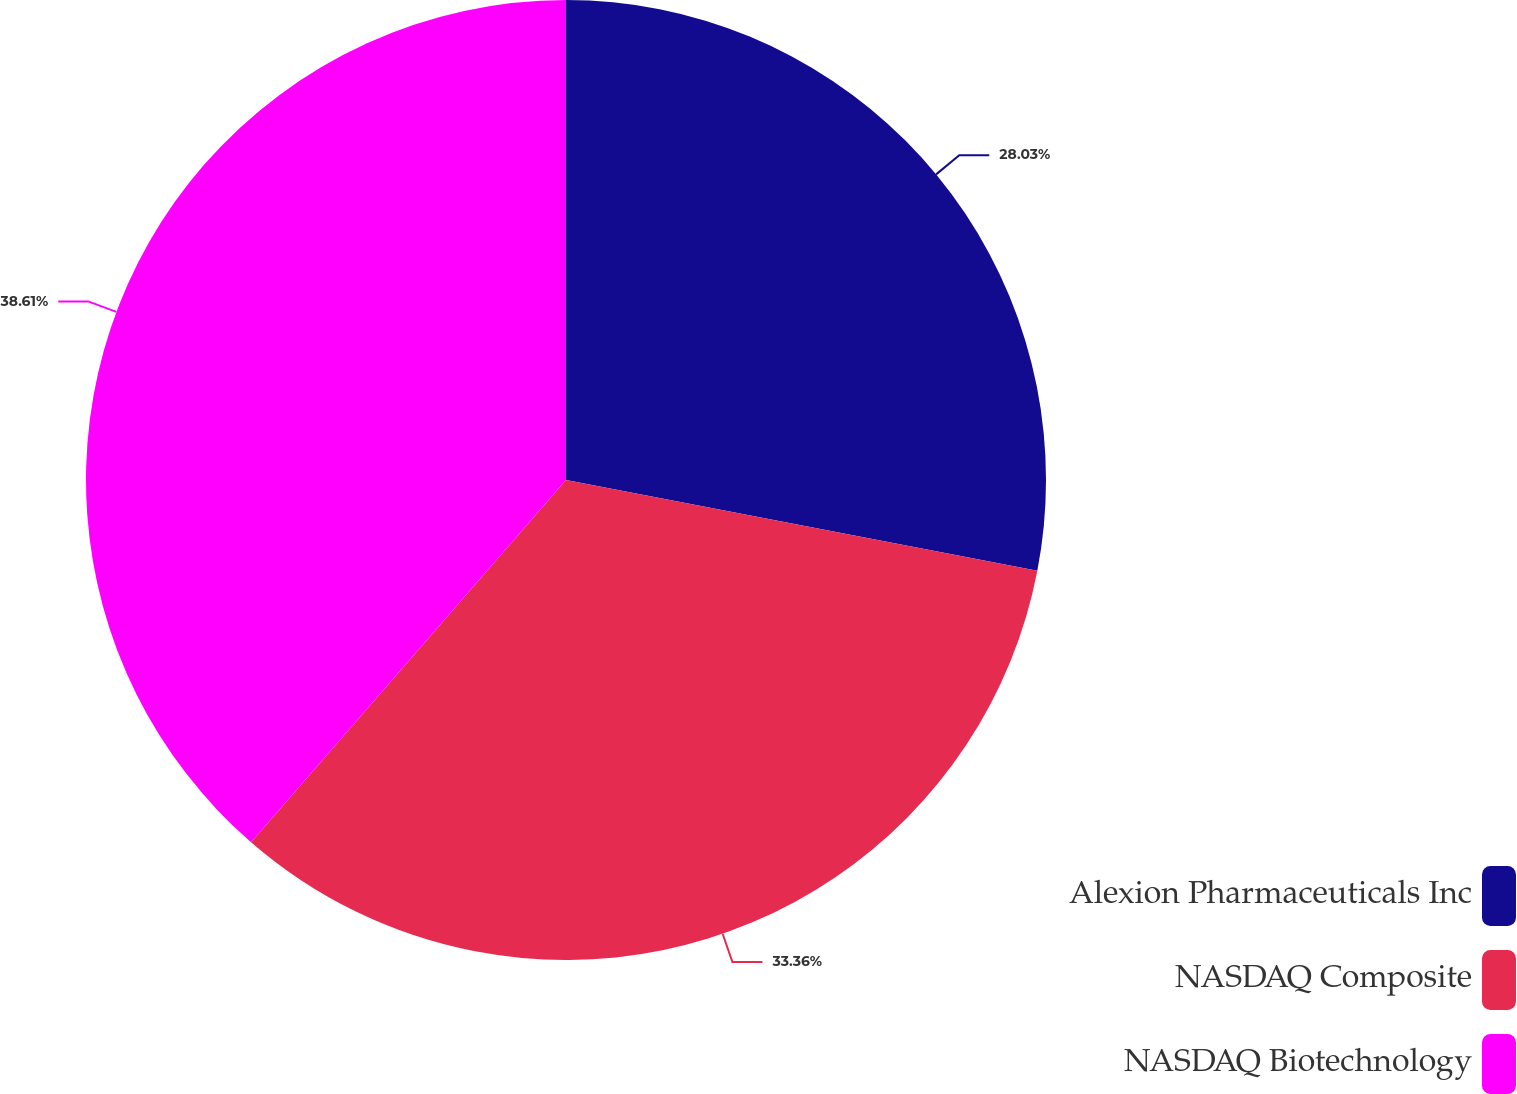<chart> <loc_0><loc_0><loc_500><loc_500><pie_chart><fcel>Alexion Pharmaceuticals Inc<fcel>NASDAQ Composite<fcel>NASDAQ Biotechnology<nl><fcel>28.03%<fcel>33.36%<fcel>38.61%<nl></chart> 